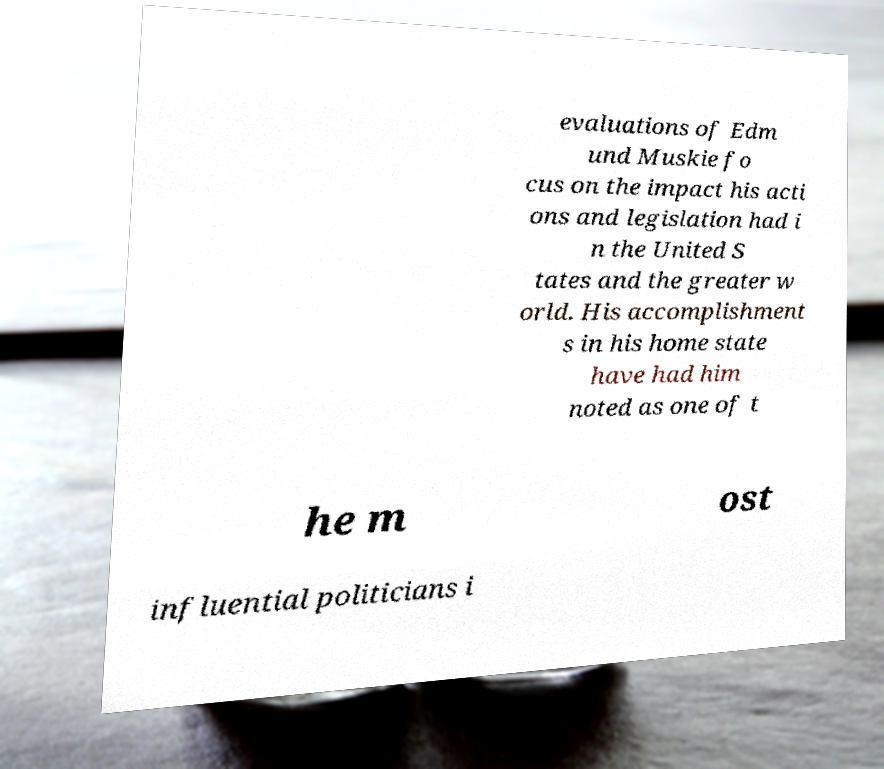What messages or text are displayed in this image? I need them in a readable, typed format. evaluations of Edm und Muskie fo cus on the impact his acti ons and legislation had i n the United S tates and the greater w orld. His accomplishment s in his home state have had him noted as one of t he m ost influential politicians i 